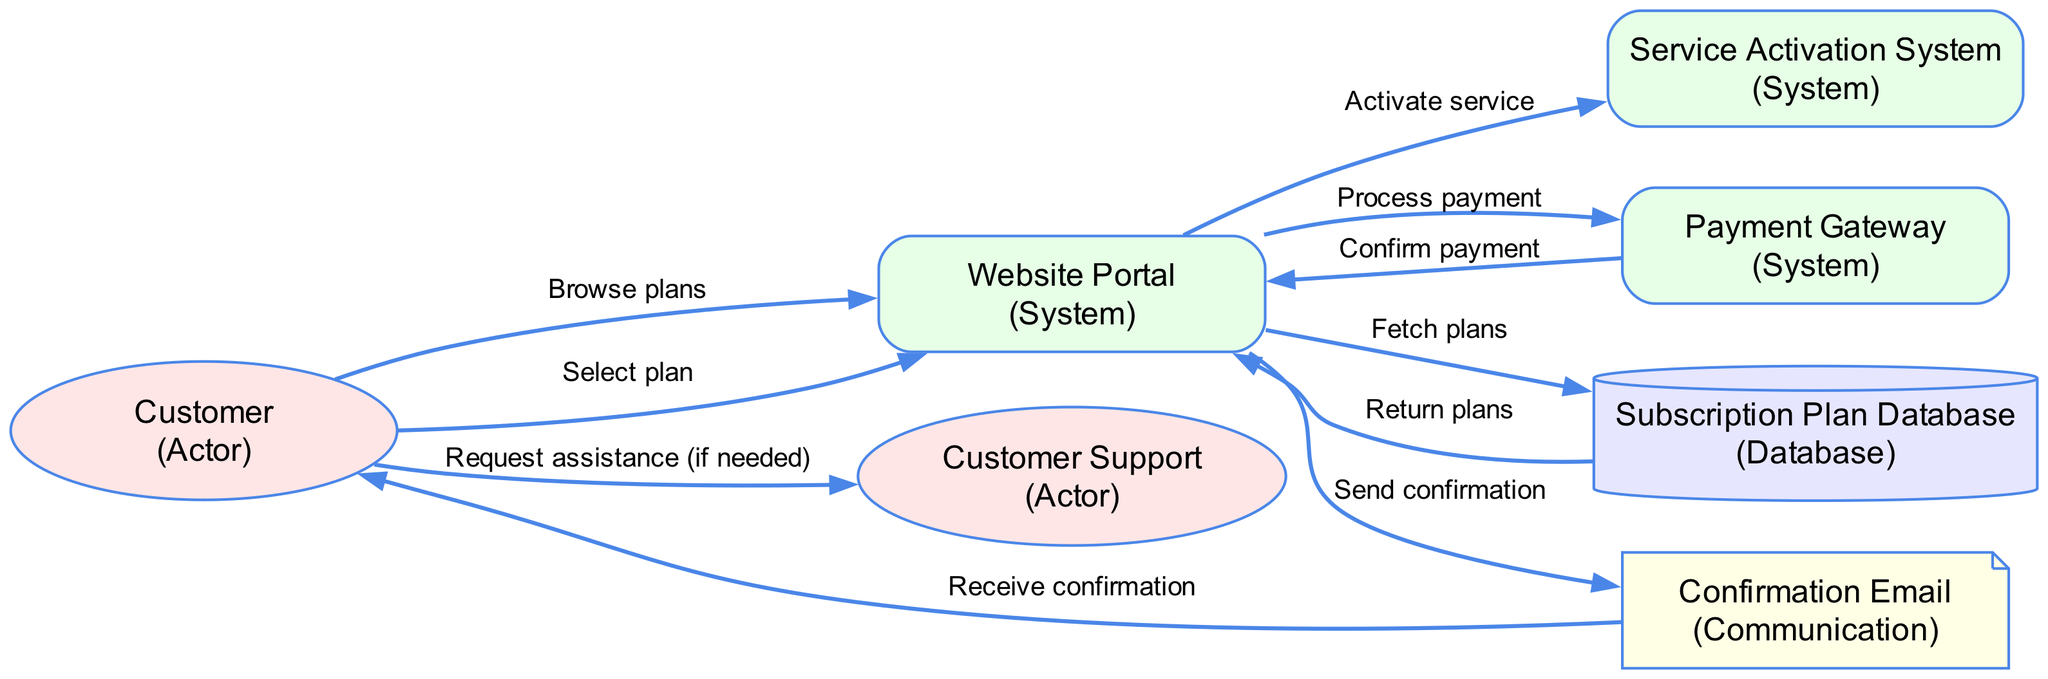What is the total number of nodes in the diagram? The diagram contains six nodes: Customer, Website Portal, Payment Gateway, Subscription Plan Database, Confirmation Email, and Customer Support.
Answer: 6 What type of node is the "Subscription Plan Database"? According to the legend provided in the diagram, the Subscription Plan Database is categorized as a Database node which is typically represented in a specific shape.
Answer: Database What action follows "Select plan"? From the diagram, after the action "Select plan" by the Customer, the next interaction is the Website Portal processing the payment through the Payment Gateway.
Answer: Process payment How many edges originate from the "Website Portal"? The Website Portal has five outgoing edges as it interacts with the Subscription Plan Database, the Payment Gateway, the Confirmation Email, and the Service Activation System.
Answer: 5 Which actor can the customer contact for assistance? The diagram indicates that the Customer can contact Customer Support if they need assistance during the subscription process.
Answer: Customer Support What is sent to the Customer after activating the service? After the service is activated, the Confirmation Email is sent to the Customer as a confirmation of the subscription.
Answer: Confirmation Email What is the first action taken by the Customer? The first action taken by the Customer, as per the diagram, is browsing the plans available on the Website Portal.
Answer: Browse plans Why does the Website Portal communicate with the Subscription Plan Database? The communication between the Website Portal and the Subscription Plan Database is necessary to fetch available subscription plans for the Customer to view.
Answer: Fetch plans 